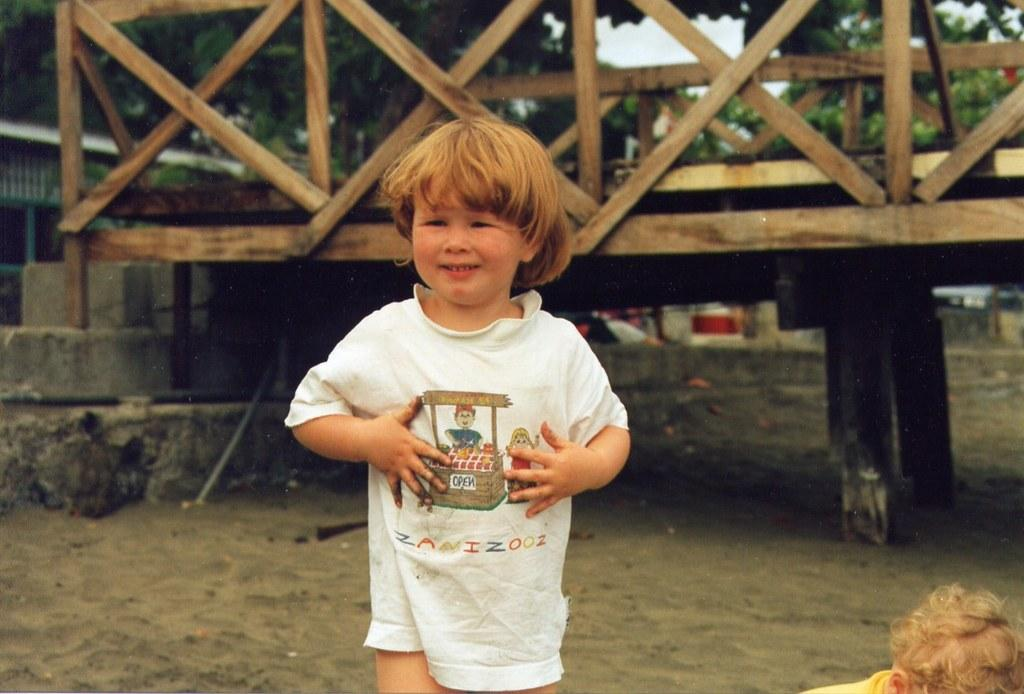How many children are in the image? There are two children on the ground in the image. What structure can be seen in the image? There is a wooden bridge in the image. What type of vegetation is present in the image? Trees are present in the image. What is visible in the background of the image? The sky is visible in the background of the image. What type of lipstick is the child wearing in the image? There is no lipstick or child wearing lipstick present in the image. What is the condition of the sock on the child's foot in the image? There is no sock or child wearing a sock present in the image. 